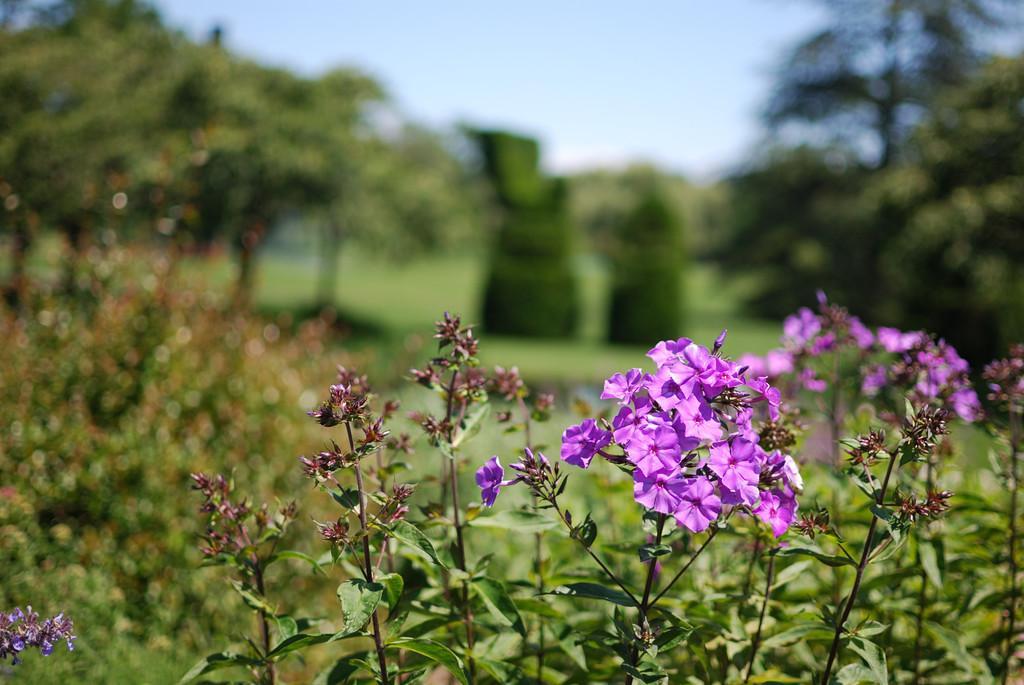How would you summarize this image in a sentence or two? In this picture there is a purple color flower plant. Behind there is a blur background and some trees. 